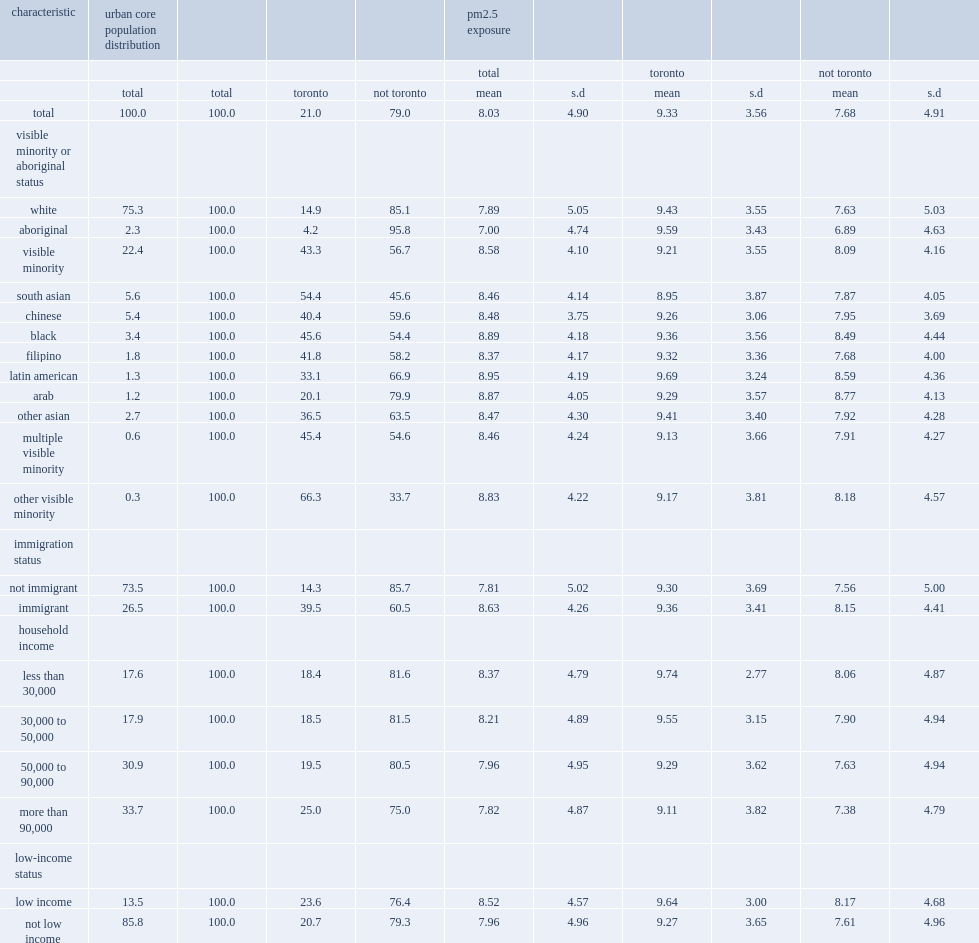Which one has a higher mean pm2.5 exposure, the toronto urban core or urban cores outside toronto? Toronto. Among urban core residents,what is the percentage of members of visible minorities who lived in toronto? 43.3. Among urban core residents,what is the percentage of whites who lived in toronto? 14.9. What is the percentage of urban core non-immigrants who lived in toronto? 14.3. 